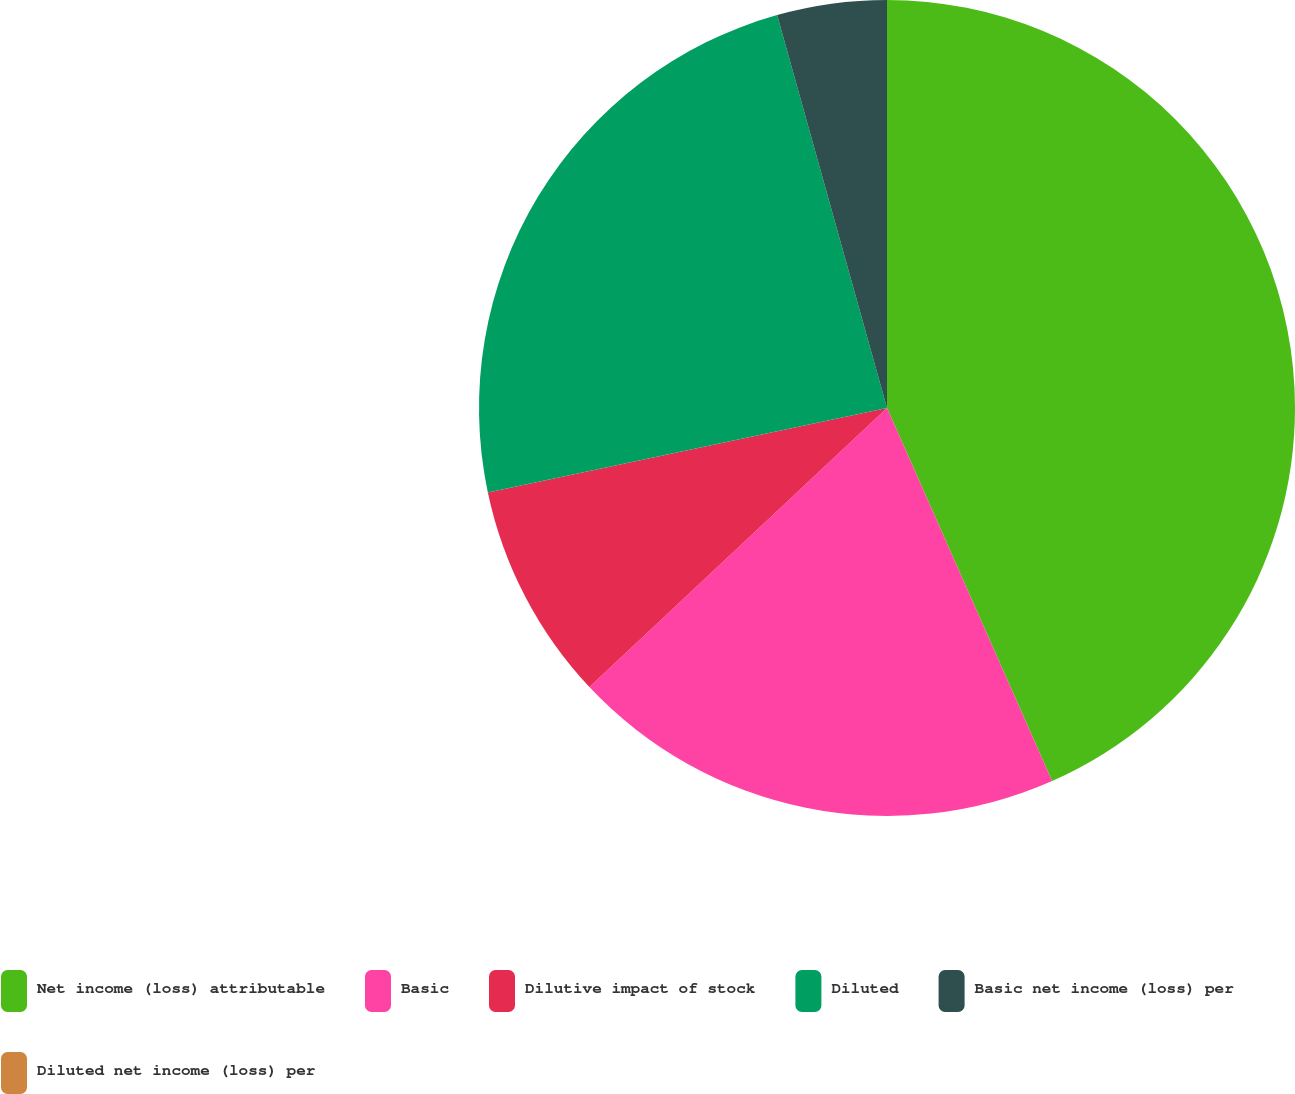Convert chart. <chart><loc_0><loc_0><loc_500><loc_500><pie_chart><fcel>Net income (loss) attributable<fcel>Basic<fcel>Dilutive impact of stock<fcel>Diluted<fcel>Basic net income (loss) per<fcel>Diluted net income (loss) per<nl><fcel>43.37%<fcel>19.64%<fcel>8.67%<fcel>23.98%<fcel>4.34%<fcel>0.0%<nl></chart> 